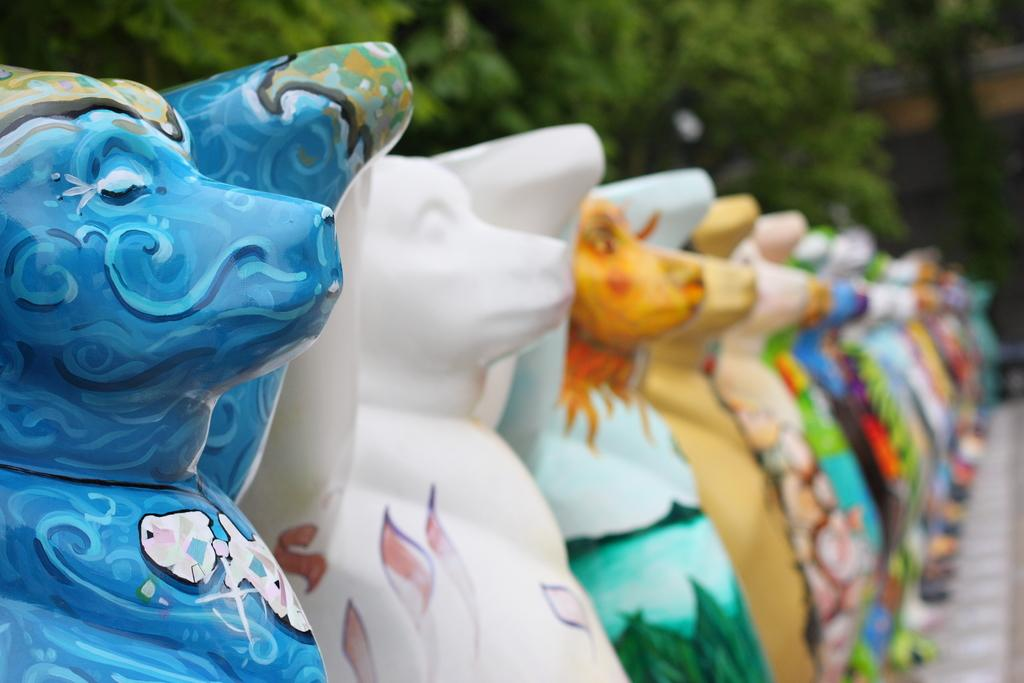What can be observed about the objects in the image? The objects in the image are colorful. What is visible in the background of the image? There are trees in the background of the image. How would you describe the background view? The background view appears blurred. Are there any slaves depicted in the image? There is no mention of slaves or any related subject matter in the image or the provided facts. 